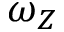Convert formula to latex. <formula><loc_0><loc_0><loc_500><loc_500>\omega _ { Z }</formula> 